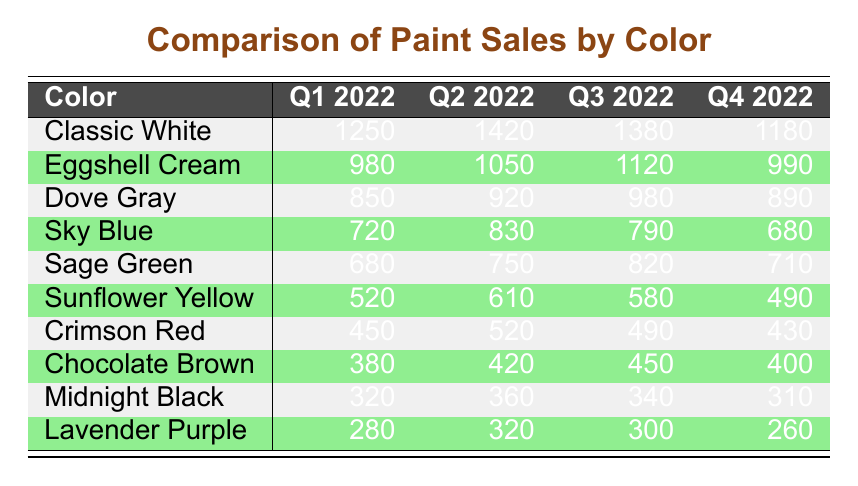What was the highest paint sales color in Q2 2022? Looking at the sales figures for Q2 2022, Classic White sold 1420 units, which is the highest among all colors.
Answer: Classic White What were the total sales of Classic White and Eggshell Cream combined over the four quarters? For Classic White, the quarterly sales are 1250, 1420, 1380, and 1180, summing to 4250. For Eggshell Cream, the sales are 980, 1050, 1120, and 990, summing to 4140. Combining both totals gives 4250 + 4140 = 8390.
Answer: 8390 Did Sage Green have higher sales than Sunflower Yellow in Q3 2022? The sales for Sage Green in Q3 2022 were 820, while Sunflower Yellow had sales of 580. Since 820 is greater than 580, Sage Green did have higher sales.
Answer: Yes What is the average sales figure for Midnight Black over the four quarters? The sales figures for Midnight Black in the four quarters are 320, 360, 340, and 310. The total sales are 320 + 360 + 340 + 310 = 1330. The average is then calculated as 1330 divided by 4, which equals 332.5.
Answer: 332.5 Which color had the lowest sales in Q1 2022? In Q1 2022, the sales figures for all colors are compared: Classic White (1250), Eggshell Cream (980), Dove Gray (850), and so on. The lowest is seen with Lavender Purple at 280.
Answer: Lavender Purple What was the difference in sales between Q1 2022 and Q4 2022 for Dove Gray? In Q1 2022, Dove Gray sold 850, while in Q4 2022, it sold 890. Calculating the difference gives 890 - 850 = 40, indicating an increase in sales from Q1 to Q4.
Answer: 40 Did the sales of Crimson Red decrease over the four quarters? The sales figures for Crimson Red are 450 in Q1, 520 in Q2, 490 in Q3, and 430 in Q4. The values show that it increased from Q1 to Q2, then decreased, and continued to decrease in Q4; hence, overall, there was a decrease during the last periods.
Answer: Yes What was the total sales of all colors in Q2 2022? The total for Q2 2022 is calculated by adding all the sales together: 1420 (Classic White) + 1050 (Eggshell Cream) + 920 (Dove Gray) + 830 (Sky Blue) + 750 (Sage Green) + 610 (Sunflower Yellow) + 520 (Crimson Red) + 420 (Chocolate Brown) + 360 (Midnight Black) + 320 (Lavender Purple) =  8390.
Answer: 8390 Which quarter saw the highest overall sales across all colors? To find the quarter with the highest sales, we sum the sales for each quarter: Q1 (1250 + 980 + 850 + 720 + 680 + 520 + 450 + 380 + 320 + 280 =  4260), Q2 (1420 + 1050 + 920 + 830 + 750 + 610 + 520 + 420 + 360 + 320 =  6870), Q3 (1380 + 1120 + 980 + 790 + 820 + 580 + 490 + 450 + 340 + 300 =  6940), Q4 (1180 + 990 + 890 + 680 + 710 + 490 + 430 + 400 + 310 + 260 =  5740). Q3 has the highest total at 6940.
Answer: Q3 2022 